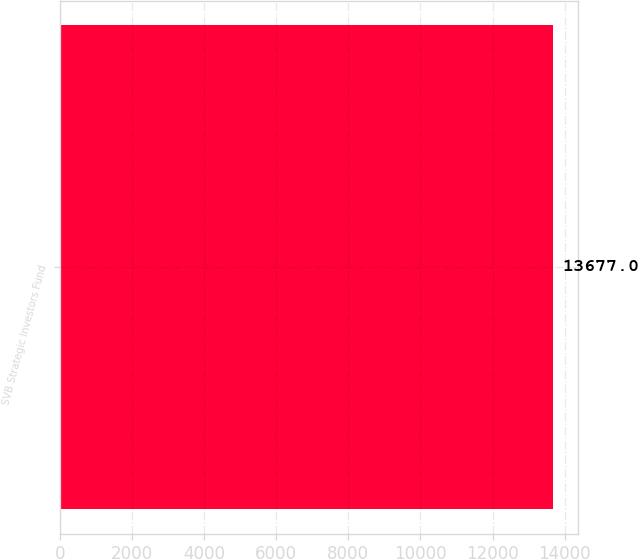Convert chart to OTSL. <chart><loc_0><loc_0><loc_500><loc_500><bar_chart><fcel>SVB Strategic Investors Fund<nl><fcel>13677<nl></chart> 